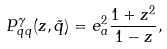<formula> <loc_0><loc_0><loc_500><loc_500>P ^ { \gamma } _ { q q } ( z , \tilde { q } ) = e _ { a } ^ { 2 } \frac { 1 + z ^ { 2 } } { 1 - z } ,</formula> 